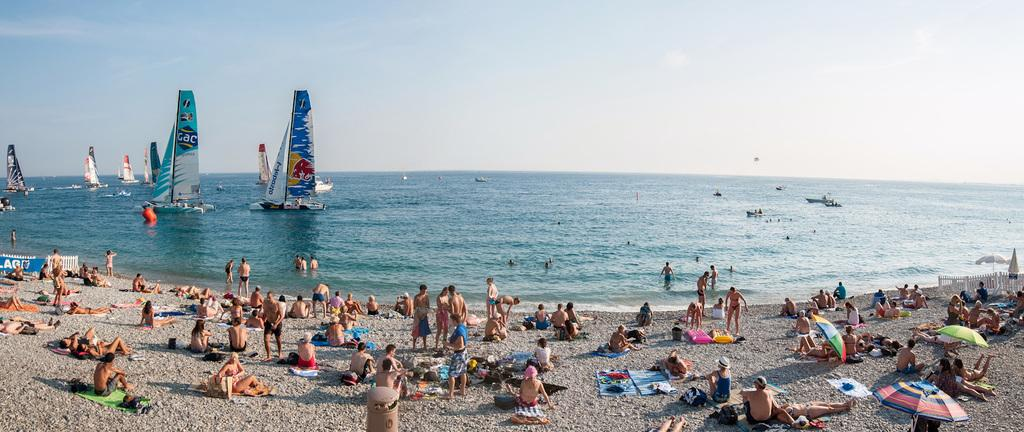What are the people in the image doing near the sea shore? There are people standing and sitting near the sea shore. What can be seen in the water near the sea shore? There is a sailboat in the water. What type of income can be seen in the image? There is no reference to income in the image, as it features people near the sea shore and a sailboat in the water. 